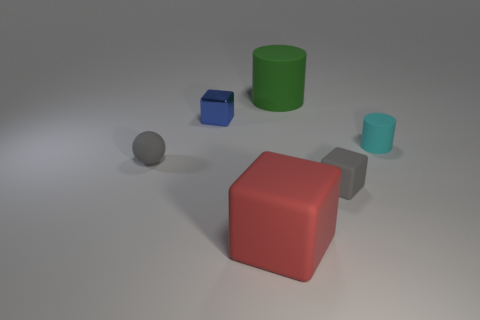Add 1 tiny spheres. How many objects exist? 7 Subtract all tiny blue metallic cubes. How many cubes are left? 2 Subtract all red cubes. How many cubes are left? 2 Subtract all cylinders. How many objects are left? 4 Subtract 1 cylinders. How many cylinders are left? 1 Subtract all red spheres. How many yellow cubes are left? 0 Subtract all large brown rubber things. Subtract all tiny metal objects. How many objects are left? 5 Add 3 cylinders. How many cylinders are left? 5 Add 2 green metal things. How many green metal things exist? 2 Subtract 0 red cylinders. How many objects are left? 6 